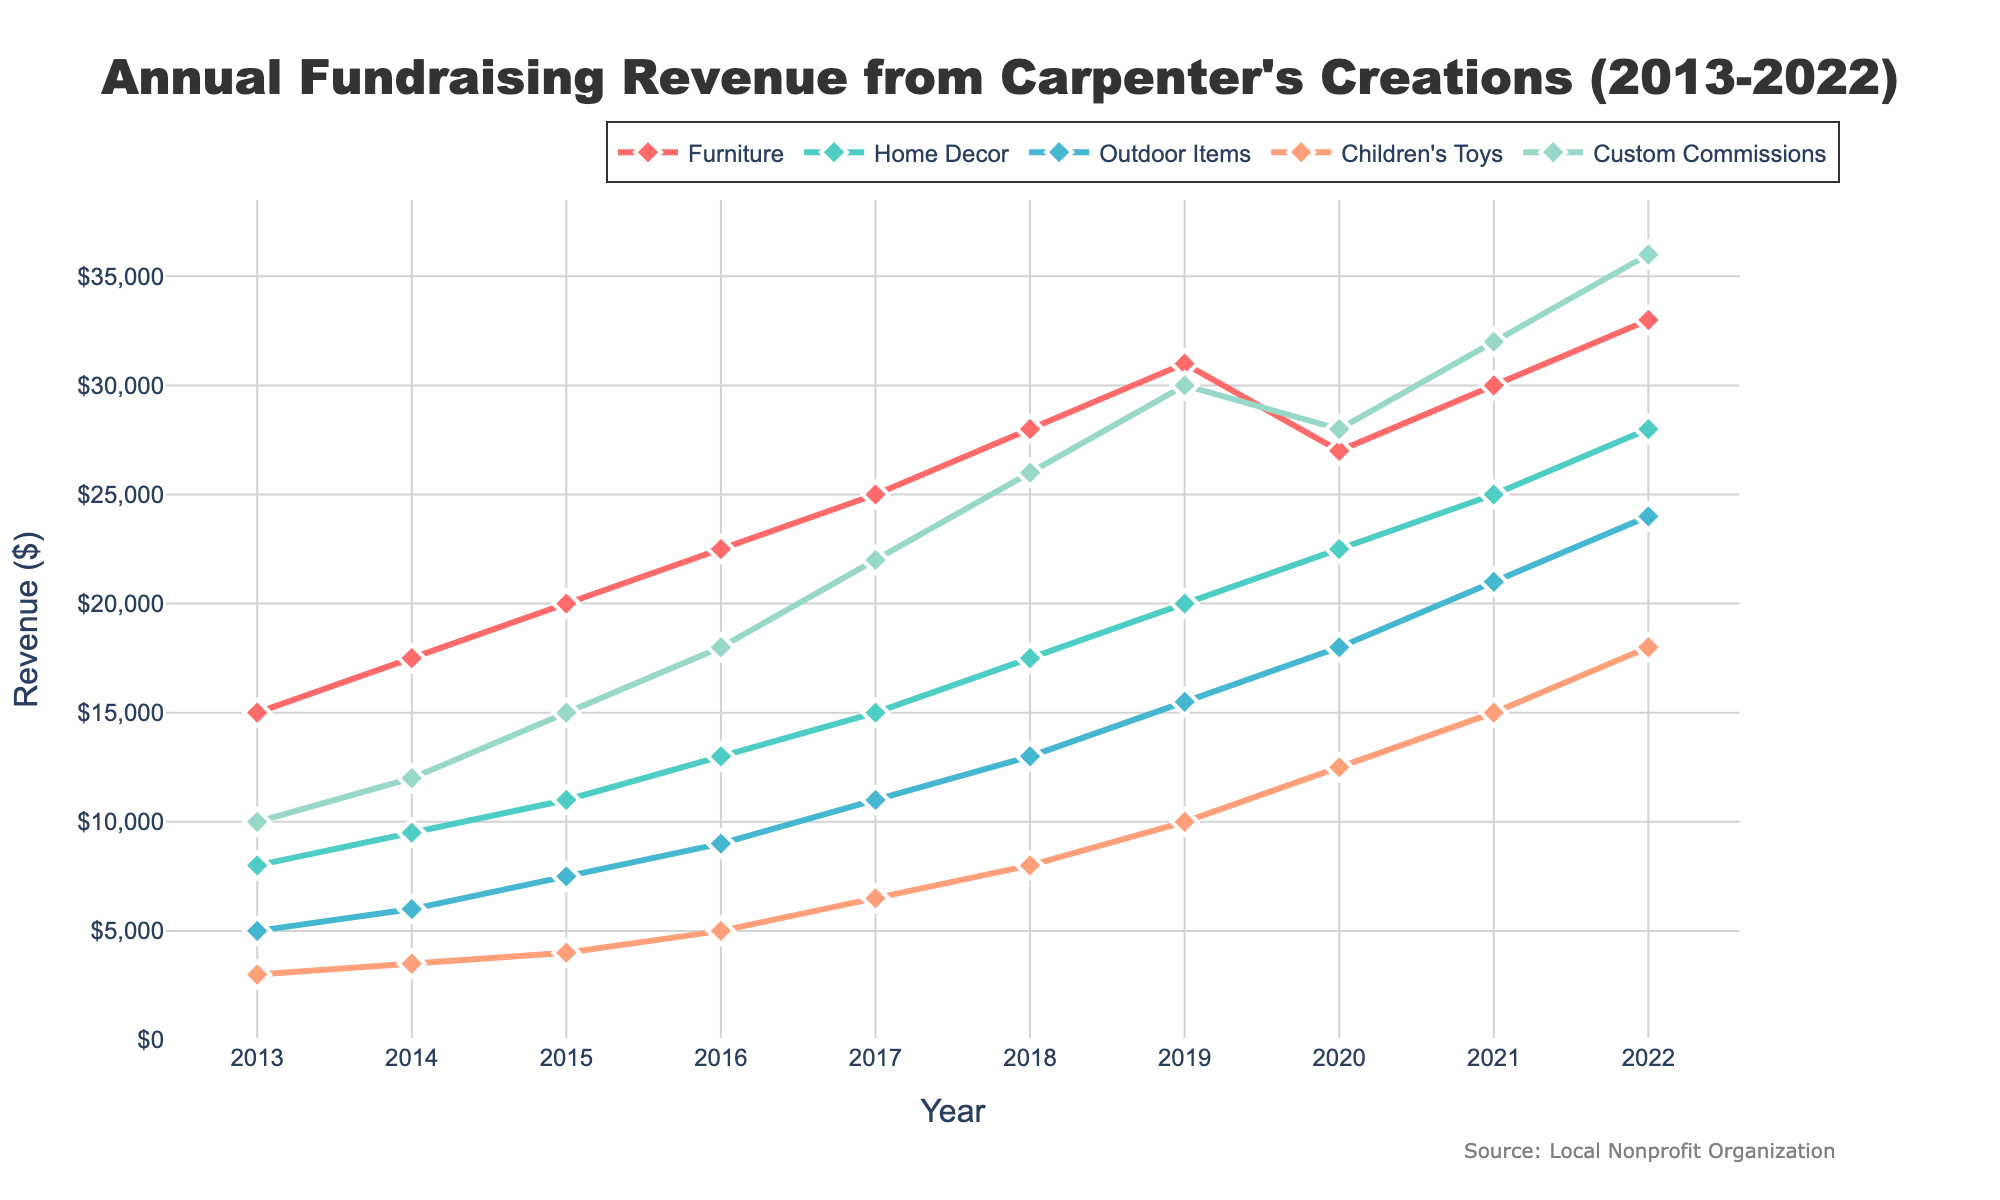What is the total revenue for 2016 across all product categories? To find the total revenue for 2016, sum the revenue from all product categories for that year: 22,500 (Furniture) + 13,000 (Home Decor) + 9,000 (Outdoor Items) + 5,000 (Children's Toys) + 18,000 (Custom Commissions). The total is 67,500.
Answer: 67,500 Which product category had the highest revenue in 2019? By looking at the line chart, identify the category with the highest position in 2019. Custom Commissions had the highest revenue in 2019.
Answer: Custom Commissions How much did the revenue from Furniture change from 2017 to 2018? To find the change, subtract the 2017 revenue from the 2018 revenue for Furniture: 28,000 - 25,000 = 3,000. The revenue increased by 3,000.
Answer: 3,000 Which product category showed the greatest percentage increase in revenue from 2021 to 2022? To find the percentage increase, use the formula [(new value - old value) / old value] * 100 for each category from 2021 to 2022. Custom Commissions had the largest percentage increase: [(36,000 - 32,000) / 32,000] * 100 = 12.5%.
Answer: Custom Commissions What is the average revenue from Home Decor over the past decade? To find the average, add the annual revenues for Home Decor from 2013 to 2022 and then divide by the number of years. (8,000 + 9,500 + 11,000 + 13,000 + 15,000 + 17,500 + 20,000 + 22,500 + 25,000 + 28,000) / 10 = 17,250.
Answer: 17,250 In which year did Outdoor Items surpass Children's Toys in terms of revenue for the first time? By examining the lines for Outdoor Items and Children's Toys, Outdoor Items surpasses Children's Toys between 2015 and 2016.
Answer: 2016 What is the difference in revenue between Custom Commissions and Home Decor in 2022? To find the difference, subtract the revenue of Home Decor from Custom Commissions in 2022: 36,000 - 28,000 = 8,000.
Answer: 8,000 Which product category consistently grew every year over the past decade? By tracing each line, Custom Commissions increased every year without any drops.
Answer: Custom Commissions What was the percentage decrease in revenue from Furniture from 2019 to 2020? Calculate the percentage decrease: [(31,000 - 27,000) / 31,000] * 100 = 12.9%.
Answer: 12.9% What is the median revenue for Children's Toys over the past decade? List the revenue values for Children's Toys from 2013 to 2022 in order: 3,000, 3,500, 4,000, 5,000, 6,500, 8,000, 10,000, 12,500, 15,000, 18,000. The median value is (6,500 + 8,000) / 2 = 7,250.
Answer: 7,250 